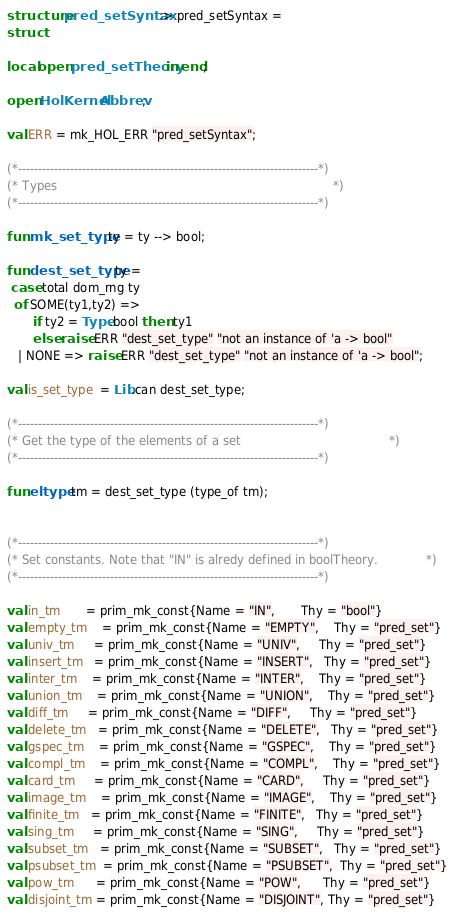<code> <loc_0><loc_0><loc_500><loc_500><_SML_>structure pred_setSyntax :> pred_setSyntax =
struct

local open pred_setTheory in end;

open HolKernel Abbrev;

val ERR = mk_HOL_ERR "pred_setSyntax";

(*---------------------------------------------------------------------------*)
(* Types                                                                     *)
(*---------------------------------------------------------------------------*)

fun mk_set_type ty = ty --> bool;

fun dest_set_type ty =
 case total dom_rng ty
  of SOME(ty1,ty2) =>
       if ty2 = Type.bool then ty1
       else raise ERR "dest_set_type" "not an instance of 'a -> bool"
   | NONE => raise ERR "dest_set_type" "not an instance of 'a -> bool";

val is_set_type  = Lib.can dest_set_type;

(*---------------------------------------------------------------------------*)
(* Get the type of the elements of a set                                     *)
(*---------------------------------------------------------------------------*)

fun eltype tm = dest_set_type (type_of tm);


(*---------------------------------------------------------------------------*)
(* Set constants. Note that "IN" is alredy defined in boolTheory.            *)
(*---------------------------------------------------------------------------*)

val in_tm       = prim_mk_const{Name = "IN",       Thy = "bool"}
val empty_tm    = prim_mk_const{Name = "EMPTY",    Thy = "pred_set"}
val univ_tm     = prim_mk_const{Name = "UNIV",     Thy = "pred_set"}
val insert_tm   = prim_mk_const{Name = "INSERT",   Thy = "pred_set"}
val inter_tm    = prim_mk_const{Name = "INTER",    Thy = "pred_set"}
val union_tm    = prim_mk_const{Name = "UNION",    Thy = "pred_set"}
val diff_tm     = prim_mk_const{Name = "DIFF",     Thy = "pred_set"}
val delete_tm   = prim_mk_const{Name = "DELETE",   Thy = "pred_set"}
val gspec_tm    = prim_mk_const{Name = "GSPEC",    Thy = "pred_set"}
val compl_tm    = prim_mk_const{Name = "COMPL",    Thy = "pred_set"}
val card_tm     = prim_mk_const{Name = "CARD",     Thy = "pred_set"}
val image_tm    = prim_mk_const{Name = "IMAGE",    Thy = "pred_set"}
val finite_tm   = prim_mk_const{Name = "FINITE",   Thy = "pred_set"}
val sing_tm     = prim_mk_const{Name = "SING",     Thy = "pred_set"}
val subset_tm   = prim_mk_const{Name = "SUBSET",   Thy = "pred_set"}
val psubset_tm  = prim_mk_const{Name = "PSUBSET",  Thy = "pred_set"}
val pow_tm      = prim_mk_const{Name = "POW",      Thy = "pred_set"}
val disjoint_tm = prim_mk_const{Name = "DISJOINT", Thy = "pred_set"}</code> 